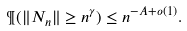Convert formula to latex. <formula><loc_0><loc_0><loc_500><loc_500>\P ( \| N _ { n } \| \geq n ^ { \gamma } ) \leq n ^ { - A + o ( 1 ) } .</formula> 